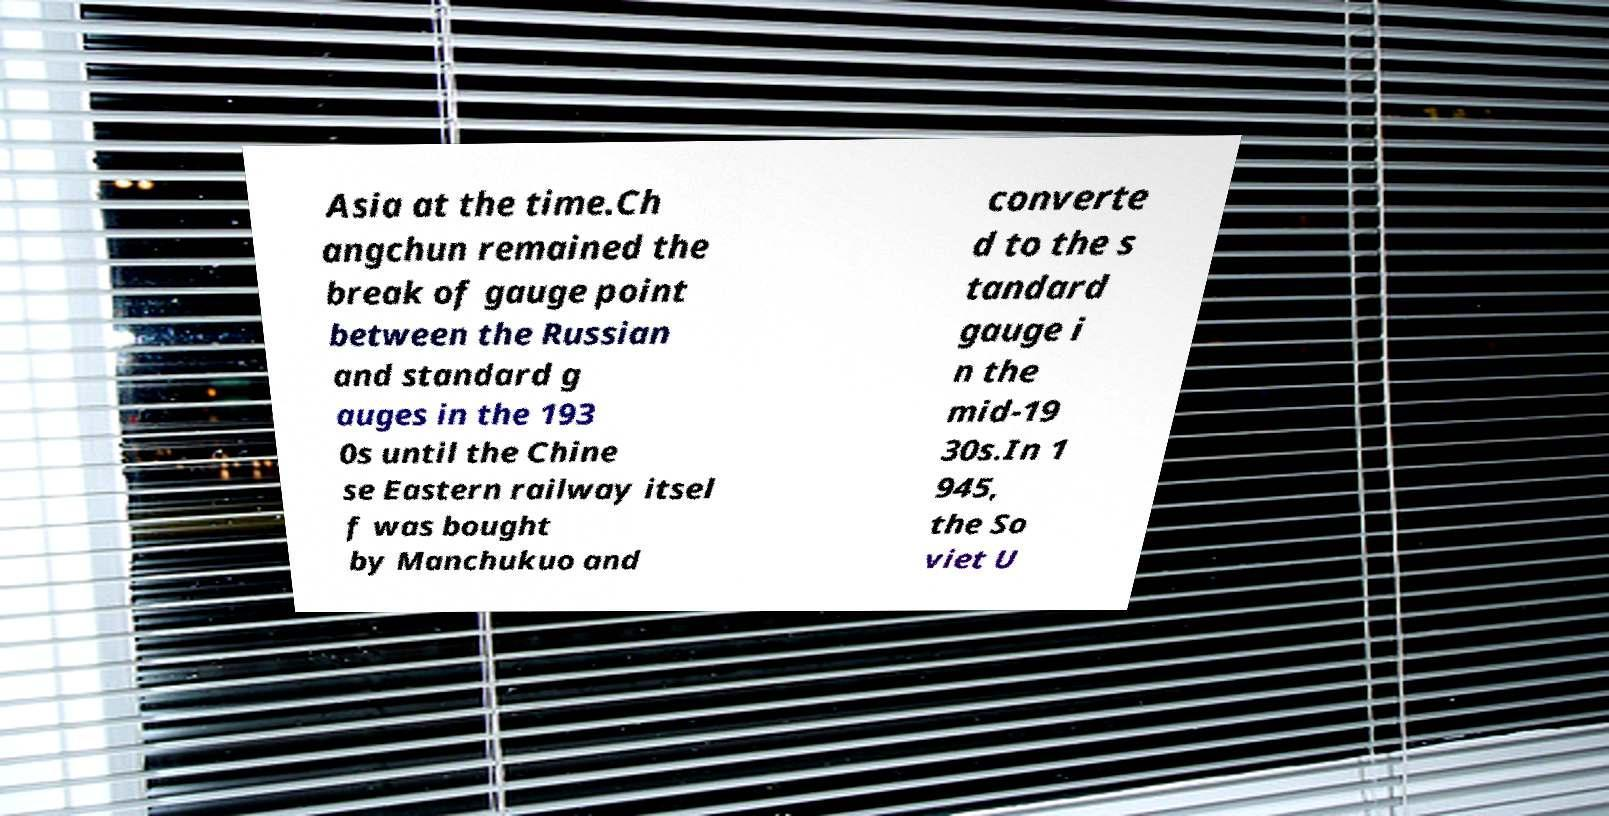Could you extract and type out the text from this image? Asia at the time.Ch angchun remained the break of gauge point between the Russian and standard g auges in the 193 0s until the Chine se Eastern railway itsel f was bought by Manchukuo and converte d to the s tandard gauge i n the mid-19 30s.In 1 945, the So viet U 